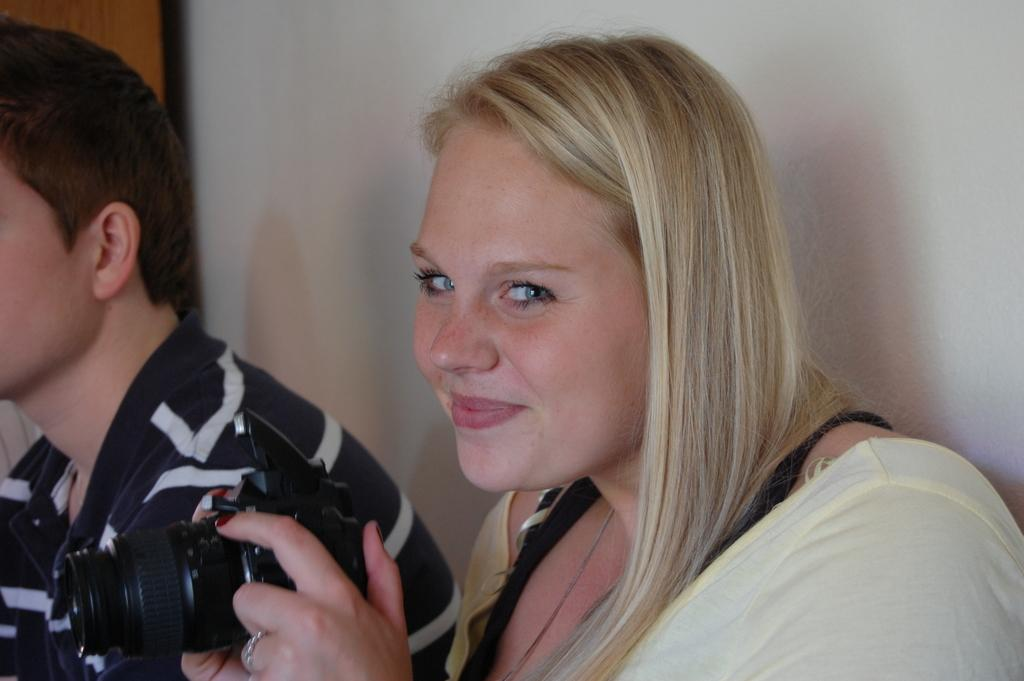What is the woman in the image holding? The woman is holding a camera in the image. What is the woman's facial expression in the image? The woman is smiling in the image. Who else is present in the image? There is a man in the image. What can be seen in the background of the image? There is a wall in the background of the image. What type of jam is the woman spreading on the wall in the image? There is no jam present in the image, nor is the woman spreading anything on the wall. 